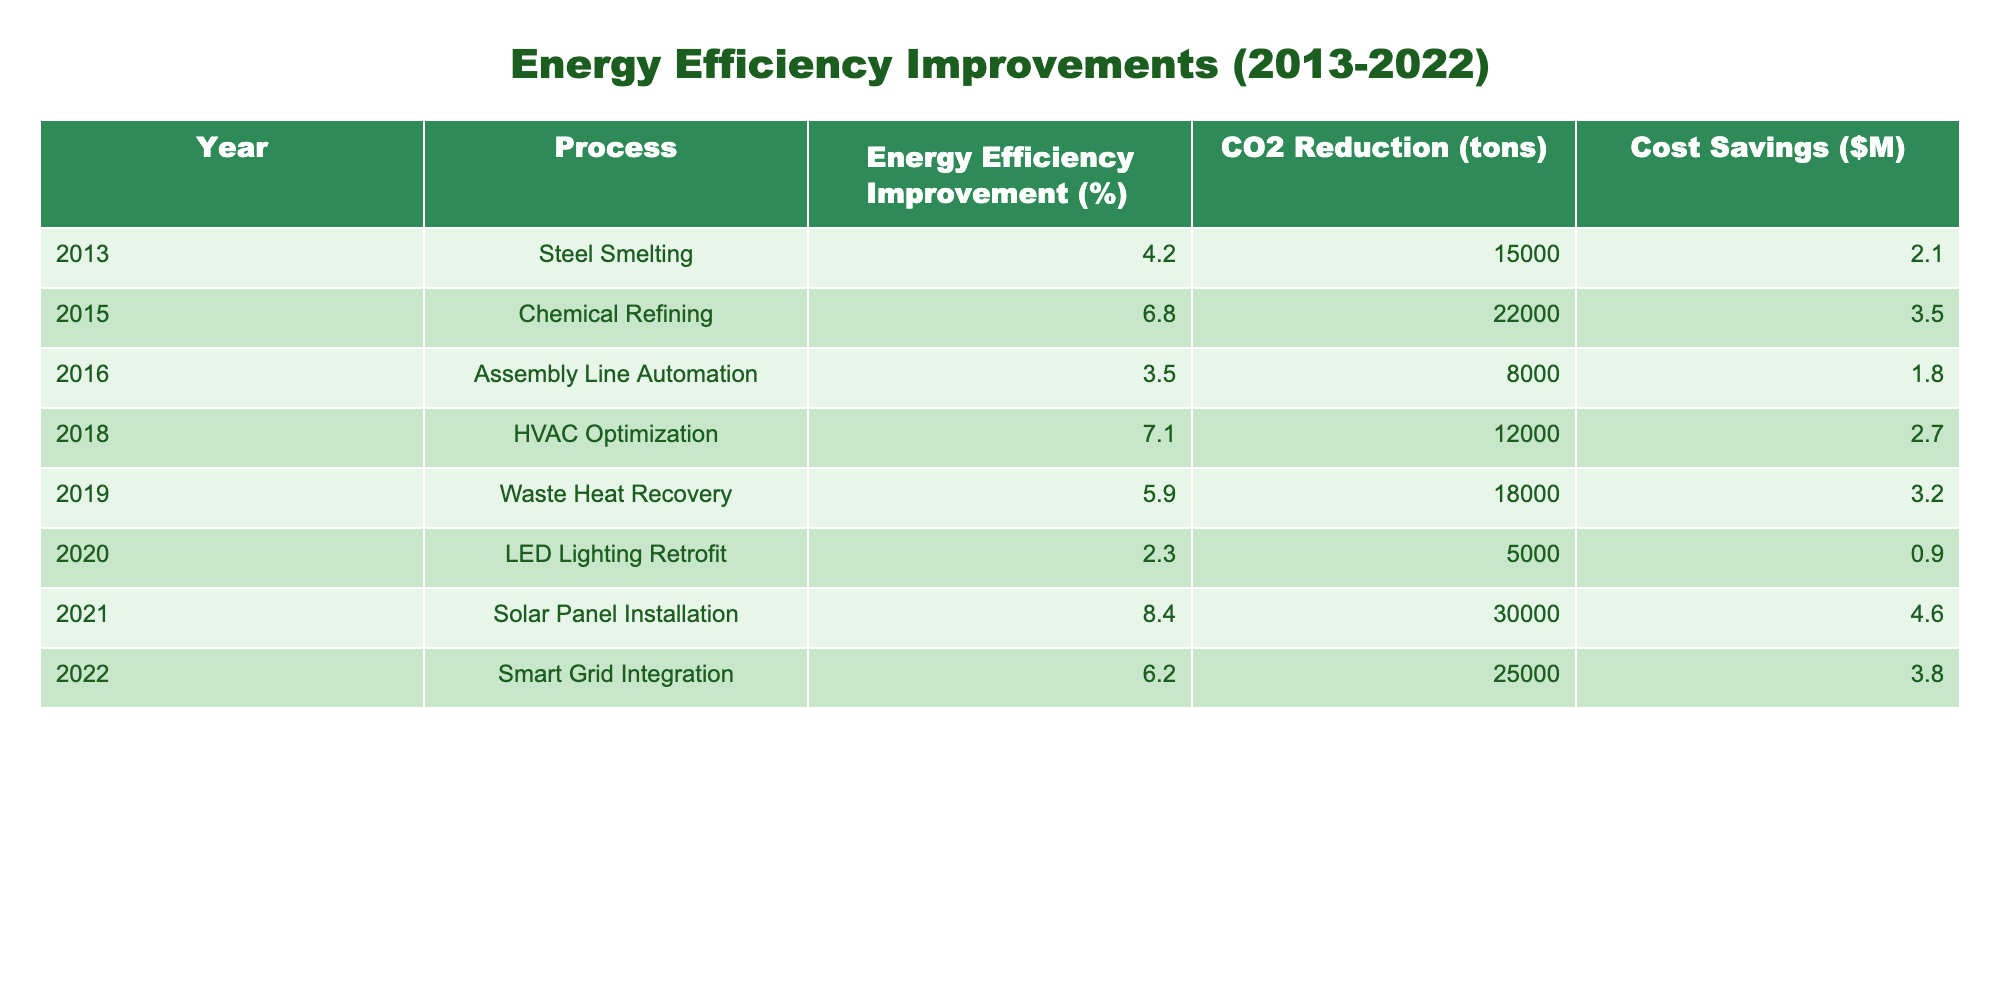What year saw the highest energy efficiency improvement? Looking at the data, in 2021, the energy efficiency improvement was 8.4%, which is the highest percentage among all the years listed.
Answer: 2021 How much CO2 was reduced in total from 2013 to 2022? By summing the CO2 reductions from each year, we have 15000 + 22000 + 8000 + 12000 + 18000 + 5000 + 30000 + 25000 = 110000 tons total CO2 reduction.
Answer: 110000 tons Which manufacturing process had the lowest energy efficiency improvement? The lowest energy efficiency improvement was in the LED Lighting Retrofit in 2020, with an improvement of 2.3%.
Answer: 2.3% Did the chemical refining process have a higher cost saving than the assembly line automation? Yes, chemical refining in 2015 had cost savings of $3.5 million, while assembly line automation in 2016 had $1.8 million in cost savings.
Answer: Yes What was the average energy efficiency improvement from 2013 to 2022? Adding all the energy efficiency improvements together gives (4.2 + 6.8 + 3.5 + 7.1 + 5.9 + 2.3 + 8.4 + 6.2 = 44.4%). Dividing by the number of processes (8) gives an average of 44.4 / 8 = 5.55%.
Answer: 5.55% Which year had the highest cost savings, and how much was it? The year 2021 had the highest cost savings of $4.6 million from solar panel installation.
Answer: $4.6 million Was there a process that had both a high energy efficiency improvement and a significant reduction in CO2? Yes, the solar panel installation in 2021 achieved an 8.4% energy efficiency improvement while reducing 30,000 tons of CO2, both being high values.
Answer: Yes What is the difference in CO2 reduction between steel smelting and chemical refining? The CO2 reduction for steel smelting was 15,000 tons, and for chemical refining, it was 22,000 tons. The difference is 22,000 - 15,000 = 7,000 tons.
Answer: 7000 tons How many processes resulted in more than a 5% energy efficiency improvement? By checking the data, the processes with more than a 5% improvement are chemical refining (6.8%), HVAC optimization (7.1%), waste heat recovery (5.9%), solar panel installation (8.4%), and smart grid integration (6.2%), totaling five processes.
Answer: 5 